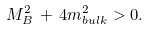<formula> <loc_0><loc_0><loc_500><loc_500>M _ { B } ^ { 2 } \, + \, 4 m _ { b u l k } ^ { 2 } > 0 .</formula> 